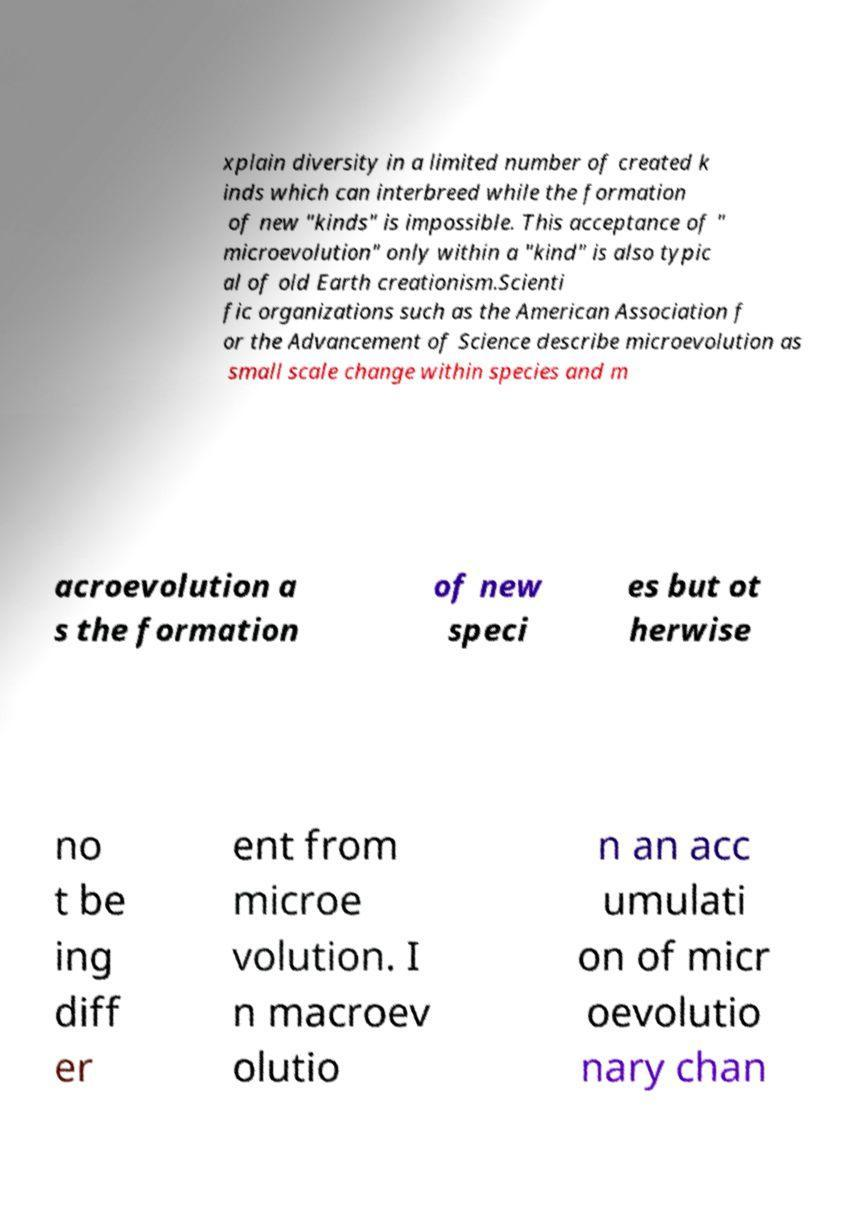What messages or text are displayed in this image? I need them in a readable, typed format. xplain diversity in a limited number of created k inds which can interbreed while the formation of new "kinds" is impossible. This acceptance of " microevolution" only within a "kind" is also typic al of old Earth creationism.Scienti fic organizations such as the American Association f or the Advancement of Science describe microevolution as small scale change within species and m acroevolution a s the formation of new speci es but ot herwise no t be ing diff er ent from microe volution. I n macroev olutio n an acc umulati on of micr oevolutio nary chan 